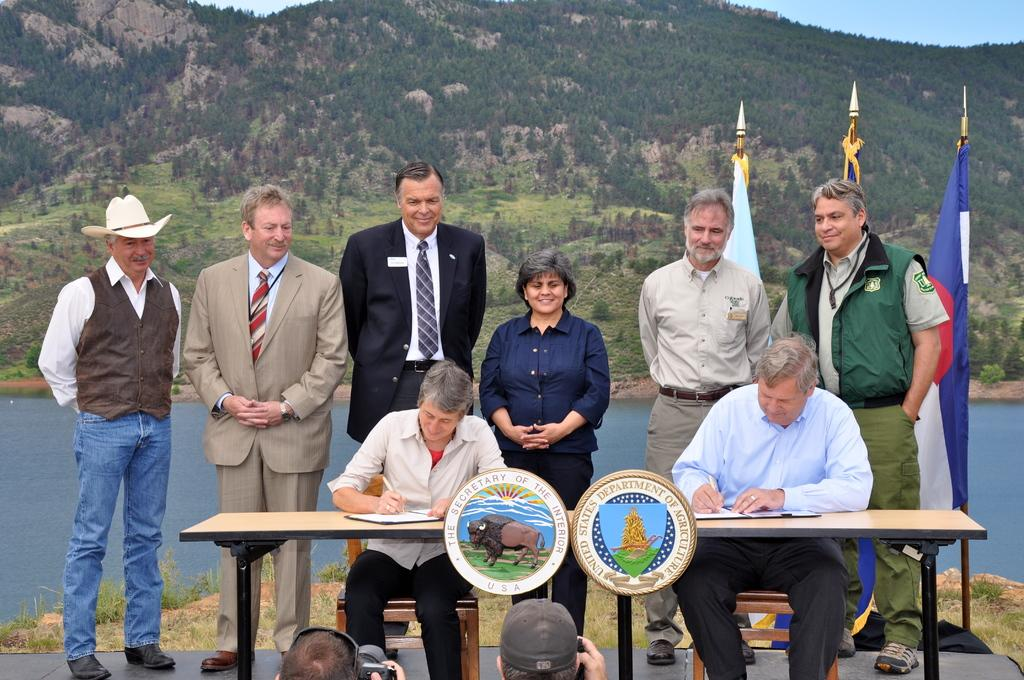What are the woman and man in the image doing? The woman and man are sitting on chairs and writing in books. How many people are standing behind them? There are 6 persons standing behind them. What can be seen in the background of the image? There is a hill, sky, and water visible in the image. Can you tell me how many kites are being flown by the people in the image? There are no kites present in the image. How many oranges are visible on the hill in the image? There are no oranges visible in the image; only a hill, sky, and water can be seen in the background. 